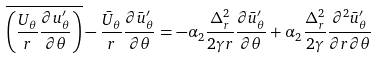<formula> <loc_0><loc_0><loc_500><loc_500>\overline { \left ( { \frac { U _ { \theta } } { r } \frac { \partial u ^ { \prime } _ { \theta } } { \partial \theta } } \right ) } - \frac { \bar { U } _ { \theta } } { r } \frac { \partial \bar { u } ^ { \prime } _ { \theta } } { \partial \theta } = - \alpha _ { 2 } \frac { \Delta _ { r } ^ { 2 } } { 2 \gamma r } \frac { \partial \bar { u } ^ { \prime } _ { \theta } } { \partial \theta } + \alpha _ { 2 } \frac { \Delta _ { r } ^ { 2 } } { 2 \gamma } \frac { \partial ^ { 2 } \bar { u } ^ { \prime } _ { \theta } } { \partial r \partial \theta }</formula> 